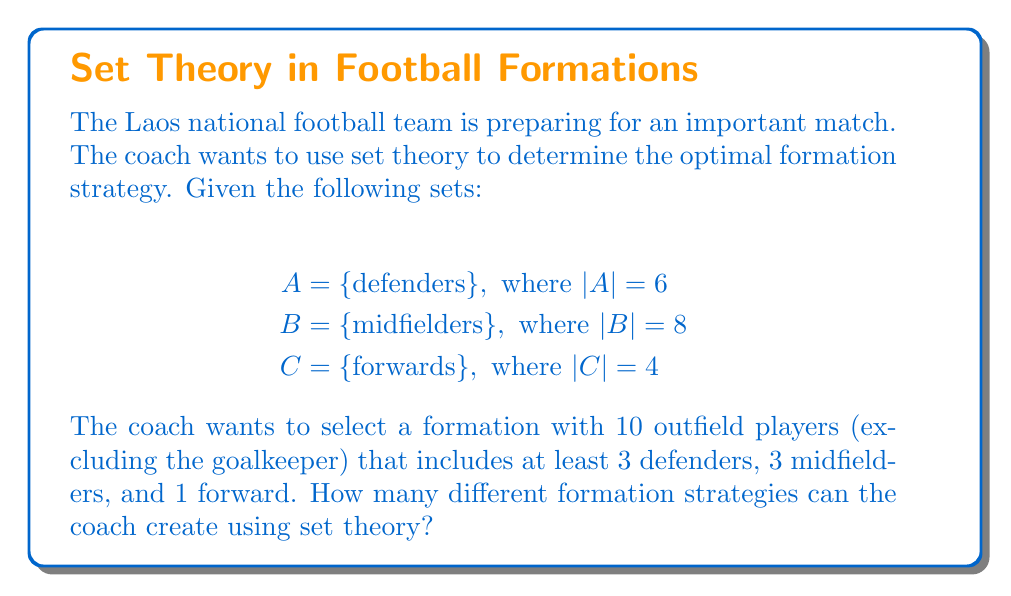What is the answer to this math problem? To solve this problem, we'll use the principles of set theory and combinatorics:

1) First, let's define the minimum requirements:
   - At least 3 defenders
   - At least 3 midfielders
   - At least 1 forward

2) This means we have 7 players fixed (3 + 3 + 1), and we need to choose 3 more players from the remaining pool.

3) The remaining pool consists of:
   - 3 defenders (6 total - 3 fixed)
   - 5 midfielders (8 total - 3 fixed)
   - 3 forwards (4 total - 1 fixed)

4) We can represent this as choosing from the union of these sets:
   $D = (A - \{3\text{ fixed defenders}\}) \cup (B - \{3\text{ fixed midfielders}\}) \cup (C - \{1\text{ fixed forward}\})$

5) $|D| = 3 + 5 + 3 = 11$

6) We need to choose 3 players from this set of 11. This can be represented as:

   $$\binom{11}{3} = \frac{11!}{3!(11-3)!} = \frac{11!}{3!8!} = 165$$

Therefore, there are 165 different ways to choose the remaining 3 players.

However, each of these 165 combinations represents a unique formation strategy, as the positions of the players within the formation can be rearranged.
Answer: The coach can create 165 different formation strategies. 